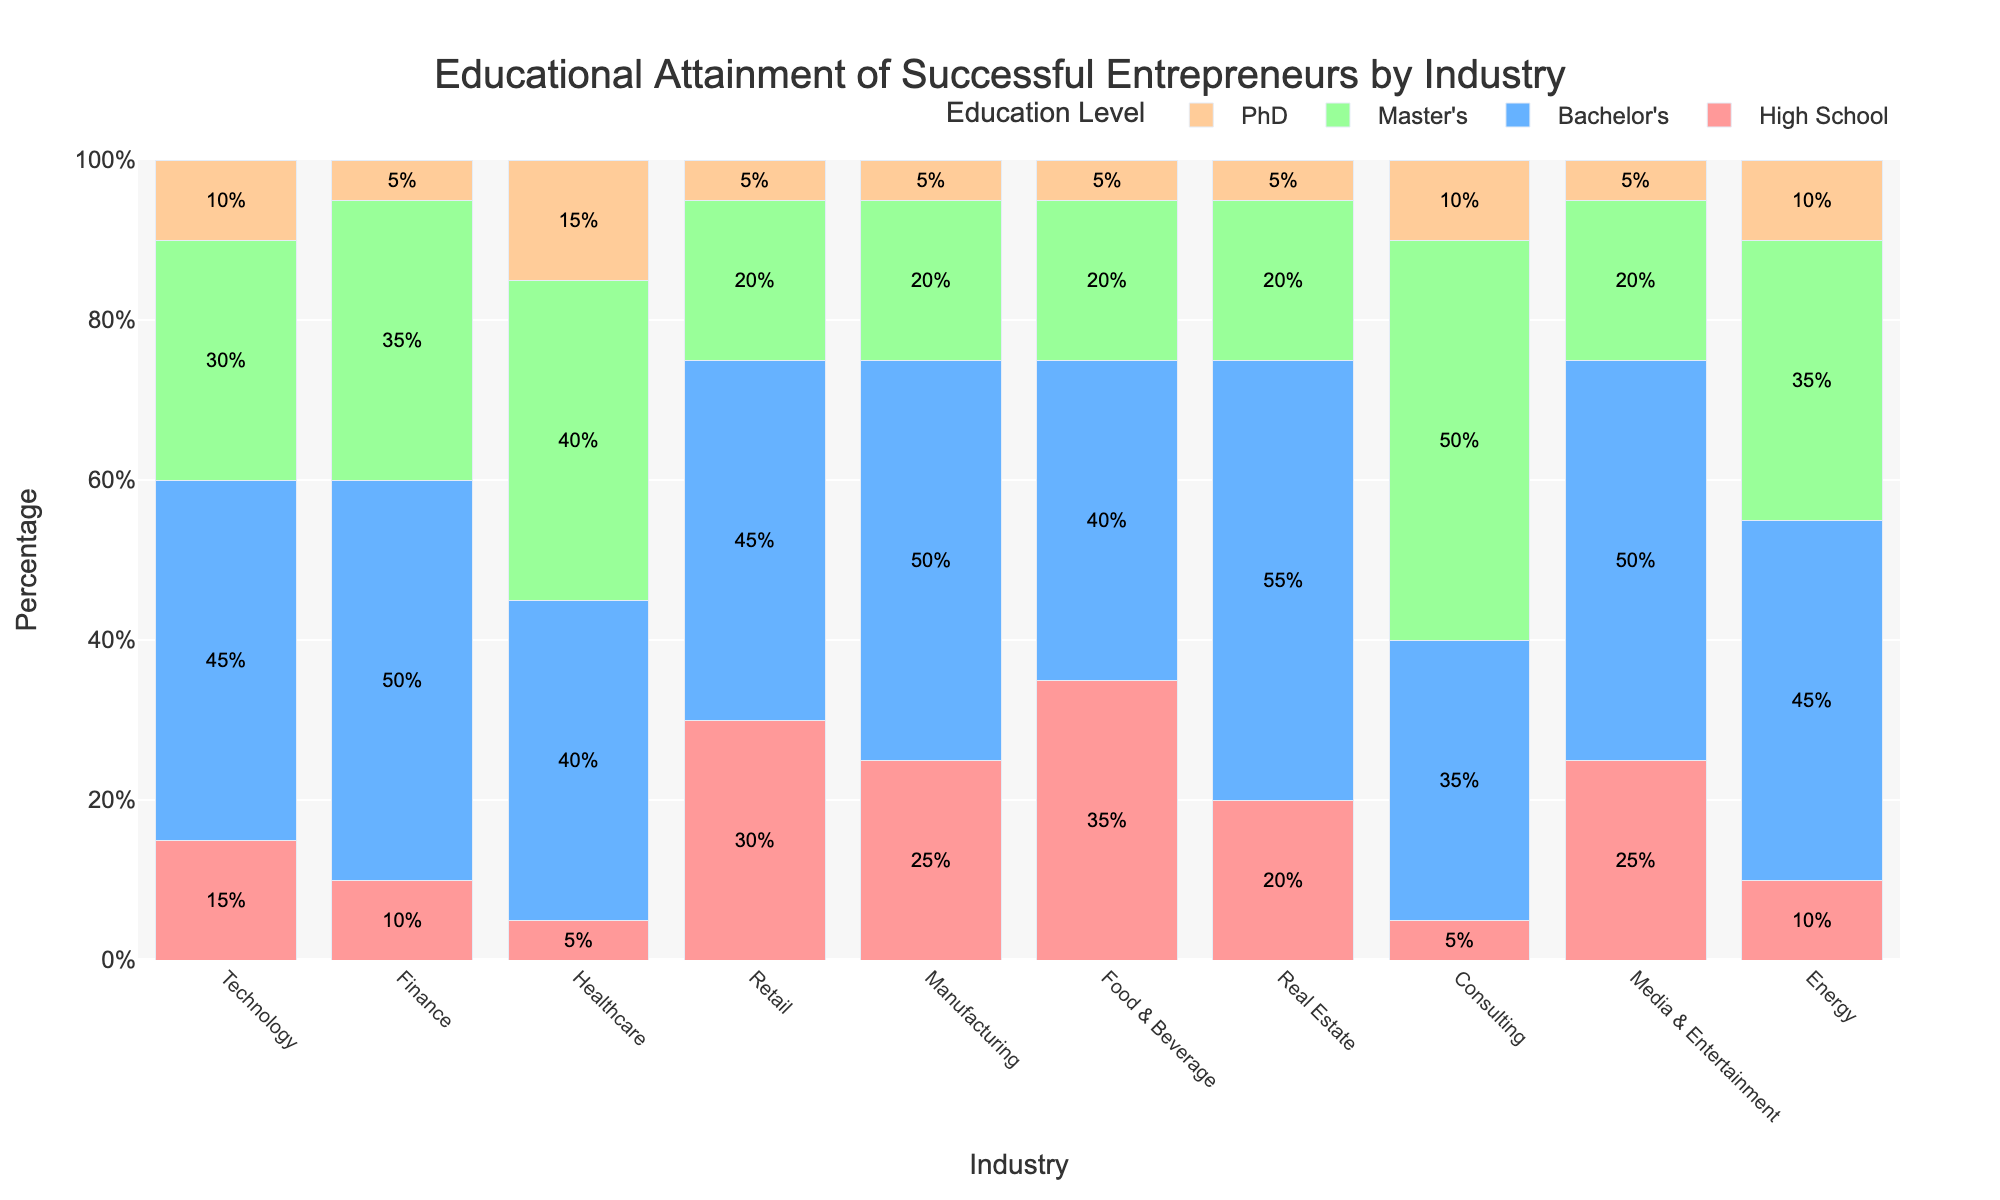What's the most common education level for successful entrepreneurs in the technology industry? The highest bar in the Technology category represents the Bachelor's level with a 45% share.
Answer: Bachelor's Among all the industries, which one has the highest percentage of successful entrepreneurs with only a high school education? The Food & Beverage industry has the highest percentage at 35%, which is higher compared to other industries.
Answer: Food & Beverage Which industry has the largest proportion of entrepreneurs with a Master's degree? Consulting has the highest percentage of entrepreneurs with a Master's degree at 50%.
Answer: Consulting What is the combined percentage of PhD entrepreneurs in Healthcare and Energy industries? Healthcare has 15% and Energy has 10% for PhD, so combined it is 15% + 10% = 25%.
Answer: 25% How does the percentage of Bachelor's degree holders compare between the Real Estate and Finance industries? Real Estate has 55% and Finance has 50%, so Real Estate is greater by 5%.
Answer: Real Estate has 5% more Which education level is least common in the Retail industry? PhD is the least common with a percentage of 5%, which is lower than other education levels in Retail.
Answer: PhD In which industry is entrepreneurship equally distributed between those with a high school education and those with a PhD? Both Retail and Real Estate have the same percentage of entrepreneurs with High School and PhD (30% High School & 5% PhD for Retail and 20% High School & 5% PhD for Real Estate).
Answer: Retail and Real Estate Which industry shows the most balanced distribution of educational levels among successful entrepreneurs? Healthcare has 5% High School, 40% Bachelor's, 40% Master's, and 15% PhD, showing a more balanced distribution.
Answer: Healthcare What is the total percentage of entrepreneurs with at least a Bachelor's degree in the Manufacturing industry? Adding Bachelor's (50%), Master's (20%), and PhD (5%), we get 50% + 20% + 5% = 75%.
Answer: 75% Compare the total percentage of entrepreneurs with a Master's degree across all industries to those with a PhD. Summing up the Master's percentages for all industries: 30 + 35 + 40 + 20 + 20 + 20 + 20 + 50 + 20 + 35 = 290%. Summing up the PhD percentages: 10 + 5 + 15 + 5 + 5 + 5 + 5 + 10 + 5 + 10 = 75%. Master's degrees are more common by 215%.
Answer: Master's degrees are 290%, PhDs are 75% 